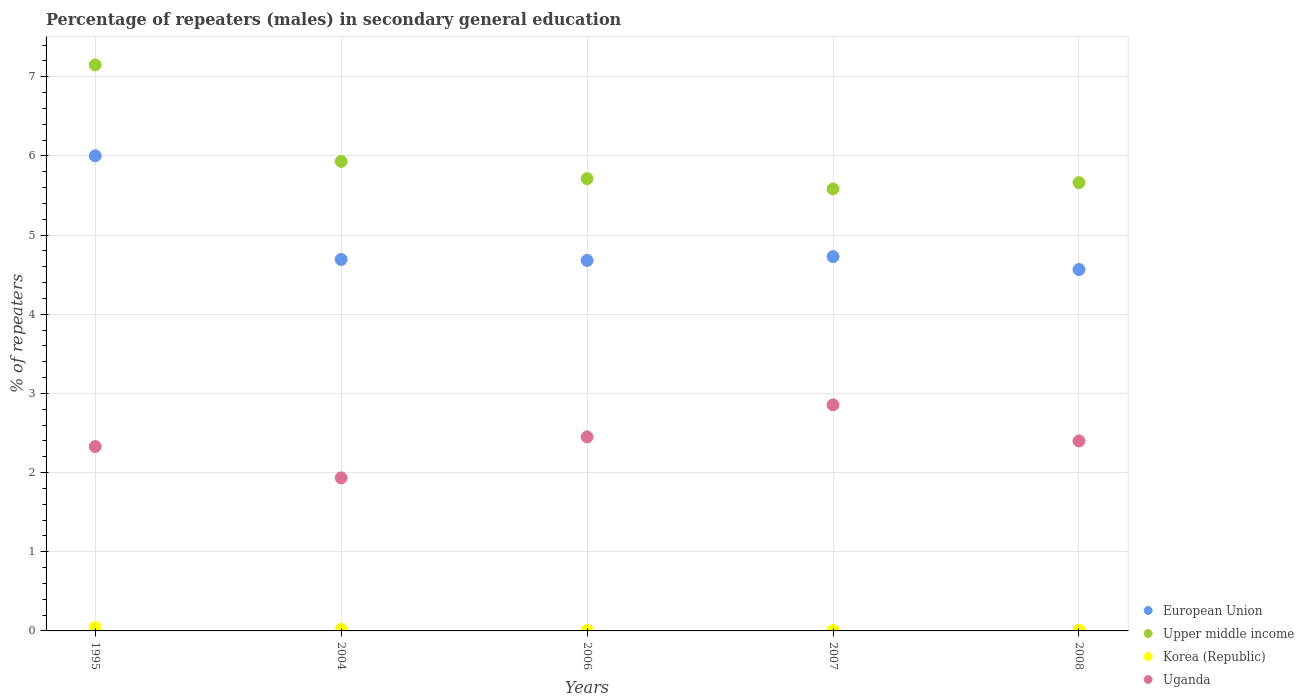How many different coloured dotlines are there?
Offer a very short reply. 4. Is the number of dotlines equal to the number of legend labels?
Provide a short and direct response. Yes. What is the percentage of male repeaters in European Union in 2008?
Offer a terse response. 4.57. Across all years, what is the maximum percentage of male repeaters in Upper middle income?
Your answer should be compact. 7.15. Across all years, what is the minimum percentage of male repeaters in Upper middle income?
Your response must be concise. 5.58. In which year was the percentage of male repeaters in European Union minimum?
Your answer should be very brief. 2008. What is the total percentage of male repeaters in Uganda in the graph?
Offer a very short reply. 11.97. What is the difference between the percentage of male repeaters in European Union in 2004 and that in 2006?
Make the answer very short. 0.01. What is the difference between the percentage of male repeaters in Korea (Republic) in 2006 and the percentage of male repeaters in Uganda in 2007?
Your response must be concise. -2.85. What is the average percentage of male repeaters in European Union per year?
Ensure brevity in your answer.  4.93. In the year 2004, what is the difference between the percentage of male repeaters in Upper middle income and percentage of male repeaters in Korea (Republic)?
Make the answer very short. 5.91. In how many years, is the percentage of male repeaters in Uganda greater than 5.2 %?
Offer a terse response. 0. What is the ratio of the percentage of male repeaters in Korea (Republic) in 2004 to that in 2008?
Make the answer very short. 2.45. Is the percentage of male repeaters in European Union in 1995 less than that in 2008?
Your answer should be compact. No. What is the difference between the highest and the second highest percentage of male repeaters in European Union?
Make the answer very short. 1.27. What is the difference between the highest and the lowest percentage of male repeaters in European Union?
Provide a succinct answer. 1.44. In how many years, is the percentage of male repeaters in European Union greater than the average percentage of male repeaters in European Union taken over all years?
Your answer should be very brief. 1. Is the sum of the percentage of male repeaters in European Union in 2006 and 2007 greater than the maximum percentage of male repeaters in Uganda across all years?
Ensure brevity in your answer.  Yes. How many years are there in the graph?
Provide a succinct answer. 5. What is the difference between two consecutive major ticks on the Y-axis?
Offer a terse response. 1. Does the graph contain any zero values?
Provide a succinct answer. No. Does the graph contain grids?
Make the answer very short. Yes. Where does the legend appear in the graph?
Keep it short and to the point. Bottom right. How are the legend labels stacked?
Ensure brevity in your answer.  Vertical. What is the title of the graph?
Your response must be concise. Percentage of repeaters (males) in secondary general education. What is the label or title of the X-axis?
Make the answer very short. Years. What is the label or title of the Y-axis?
Make the answer very short. % of repeaters. What is the % of repeaters in European Union in 1995?
Give a very brief answer. 6. What is the % of repeaters in Upper middle income in 1995?
Ensure brevity in your answer.  7.15. What is the % of repeaters in Korea (Republic) in 1995?
Your answer should be very brief. 0.04. What is the % of repeaters of Uganda in 1995?
Make the answer very short. 2.33. What is the % of repeaters in European Union in 2004?
Offer a very short reply. 4.69. What is the % of repeaters in Upper middle income in 2004?
Provide a succinct answer. 5.93. What is the % of repeaters in Korea (Republic) in 2004?
Keep it short and to the point. 0.02. What is the % of repeaters in Uganda in 2004?
Give a very brief answer. 1.93. What is the % of repeaters of European Union in 2006?
Make the answer very short. 4.68. What is the % of repeaters of Upper middle income in 2006?
Provide a short and direct response. 5.71. What is the % of repeaters of Korea (Republic) in 2006?
Your response must be concise. 0.01. What is the % of repeaters in Uganda in 2006?
Ensure brevity in your answer.  2.45. What is the % of repeaters of European Union in 2007?
Make the answer very short. 4.73. What is the % of repeaters in Upper middle income in 2007?
Provide a succinct answer. 5.58. What is the % of repeaters in Korea (Republic) in 2007?
Give a very brief answer. 0. What is the % of repeaters of Uganda in 2007?
Your answer should be compact. 2.86. What is the % of repeaters in European Union in 2008?
Keep it short and to the point. 4.57. What is the % of repeaters of Upper middle income in 2008?
Provide a short and direct response. 5.66. What is the % of repeaters of Korea (Republic) in 2008?
Your response must be concise. 0.01. What is the % of repeaters in Uganda in 2008?
Give a very brief answer. 2.4. Across all years, what is the maximum % of repeaters in European Union?
Your answer should be very brief. 6. Across all years, what is the maximum % of repeaters in Upper middle income?
Make the answer very short. 7.15. Across all years, what is the maximum % of repeaters of Korea (Republic)?
Your answer should be very brief. 0.04. Across all years, what is the maximum % of repeaters in Uganda?
Provide a succinct answer. 2.86. Across all years, what is the minimum % of repeaters in European Union?
Give a very brief answer. 4.57. Across all years, what is the minimum % of repeaters of Upper middle income?
Make the answer very short. 5.58. Across all years, what is the minimum % of repeaters in Korea (Republic)?
Provide a succinct answer. 0. Across all years, what is the minimum % of repeaters in Uganda?
Make the answer very short. 1.93. What is the total % of repeaters in European Union in the graph?
Provide a short and direct response. 24.67. What is the total % of repeaters in Upper middle income in the graph?
Your answer should be very brief. 30.04. What is the total % of repeaters in Korea (Republic) in the graph?
Provide a short and direct response. 0.08. What is the total % of repeaters in Uganda in the graph?
Provide a succinct answer. 11.97. What is the difference between the % of repeaters of European Union in 1995 and that in 2004?
Offer a very short reply. 1.31. What is the difference between the % of repeaters of Upper middle income in 1995 and that in 2004?
Make the answer very short. 1.22. What is the difference between the % of repeaters of Korea (Republic) in 1995 and that in 2004?
Offer a terse response. 0.02. What is the difference between the % of repeaters in Uganda in 1995 and that in 2004?
Keep it short and to the point. 0.4. What is the difference between the % of repeaters in European Union in 1995 and that in 2006?
Give a very brief answer. 1.32. What is the difference between the % of repeaters of Upper middle income in 1995 and that in 2006?
Your answer should be compact. 1.44. What is the difference between the % of repeaters in Korea (Republic) in 1995 and that in 2006?
Offer a terse response. 0.04. What is the difference between the % of repeaters in Uganda in 1995 and that in 2006?
Your response must be concise. -0.12. What is the difference between the % of repeaters of European Union in 1995 and that in 2007?
Provide a short and direct response. 1.27. What is the difference between the % of repeaters in Upper middle income in 1995 and that in 2007?
Offer a terse response. 1.57. What is the difference between the % of repeaters of Korea (Republic) in 1995 and that in 2007?
Keep it short and to the point. 0.04. What is the difference between the % of repeaters in Uganda in 1995 and that in 2007?
Offer a very short reply. -0.53. What is the difference between the % of repeaters in European Union in 1995 and that in 2008?
Provide a short and direct response. 1.44. What is the difference between the % of repeaters in Upper middle income in 1995 and that in 2008?
Your response must be concise. 1.49. What is the difference between the % of repeaters in Korea (Republic) in 1995 and that in 2008?
Offer a very short reply. 0.03. What is the difference between the % of repeaters of Uganda in 1995 and that in 2008?
Provide a short and direct response. -0.07. What is the difference between the % of repeaters of European Union in 2004 and that in 2006?
Offer a very short reply. 0.01. What is the difference between the % of repeaters in Upper middle income in 2004 and that in 2006?
Provide a short and direct response. 0.22. What is the difference between the % of repeaters of Korea (Republic) in 2004 and that in 2006?
Provide a short and direct response. 0.01. What is the difference between the % of repeaters in Uganda in 2004 and that in 2006?
Your answer should be compact. -0.52. What is the difference between the % of repeaters in European Union in 2004 and that in 2007?
Offer a very short reply. -0.04. What is the difference between the % of repeaters of Upper middle income in 2004 and that in 2007?
Offer a terse response. 0.35. What is the difference between the % of repeaters of Korea (Republic) in 2004 and that in 2007?
Make the answer very short. 0.02. What is the difference between the % of repeaters in Uganda in 2004 and that in 2007?
Give a very brief answer. -0.92. What is the difference between the % of repeaters in European Union in 2004 and that in 2008?
Provide a succinct answer. 0.13. What is the difference between the % of repeaters of Upper middle income in 2004 and that in 2008?
Give a very brief answer. 0.27. What is the difference between the % of repeaters of Korea (Republic) in 2004 and that in 2008?
Your response must be concise. 0.01. What is the difference between the % of repeaters of Uganda in 2004 and that in 2008?
Offer a very short reply. -0.47. What is the difference between the % of repeaters in European Union in 2006 and that in 2007?
Offer a very short reply. -0.05. What is the difference between the % of repeaters of Upper middle income in 2006 and that in 2007?
Your response must be concise. 0.13. What is the difference between the % of repeaters in Uganda in 2006 and that in 2007?
Provide a succinct answer. -0.4. What is the difference between the % of repeaters of European Union in 2006 and that in 2008?
Make the answer very short. 0.11. What is the difference between the % of repeaters in Upper middle income in 2006 and that in 2008?
Your answer should be compact. 0.05. What is the difference between the % of repeaters in Korea (Republic) in 2006 and that in 2008?
Keep it short and to the point. -0. What is the difference between the % of repeaters in Uganda in 2006 and that in 2008?
Offer a very short reply. 0.05. What is the difference between the % of repeaters in European Union in 2007 and that in 2008?
Your answer should be very brief. 0.16. What is the difference between the % of repeaters in Upper middle income in 2007 and that in 2008?
Your response must be concise. -0.08. What is the difference between the % of repeaters in Korea (Republic) in 2007 and that in 2008?
Ensure brevity in your answer.  -0. What is the difference between the % of repeaters in Uganda in 2007 and that in 2008?
Give a very brief answer. 0.46. What is the difference between the % of repeaters of European Union in 1995 and the % of repeaters of Upper middle income in 2004?
Your answer should be compact. 0.07. What is the difference between the % of repeaters of European Union in 1995 and the % of repeaters of Korea (Republic) in 2004?
Provide a succinct answer. 5.98. What is the difference between the % of repeaters in European Union in 1995 and the % of repeaters in Uganda in 2004?
Keep it short and to the point. 4.07. What is the difference between the % of repeaters in Upper middle income in 1995 and the % of repeaters in Korea (Republic) in 2004?
Offer a terse response. 7.13. What is the difference between the % of repeaters in Upper middle income in 1995 and the % of repeaters in Uganda in 2004?
Offer a very short reply. 5.22. What is the difference between the % of repeaters in Korea (Republic) in 1995 and the % of repeaters in Uganda in 2004?
Make the answer very short. -1.89. What is the difference between the % of repeaters of European Union in 1995 and the % of repeaters of Upper middle income in 2006?
Make the answer very short. 0.29. What is the difference between the % of repeaters of European Union in 1995 and the % of repeaters of Korea (Republic) in 2006?
Your response must be concise. 6. What is the difference between the % of repeaters of European Union in 1995 and the % of repeaters of Uganda in 2006?
Make the answer very short. 3.55. What is the difference between the % of repeaters of Upper middle income in 1995 and the % of repeaters of Korea (Republic) in 2006?
Keep it short and to the point. 7.15. What is the difference between the % of repeaters of Upper middle income in 1995 and the % of repeaters of Uganda in 2006?
Your answer should be very brief. 4.7. What is the difference between the % of repeaters in Korea (Republic) in 1995 and the % of repeaters in Uganda in 2006?
Make the answer very short. -2.41. What is the difference between the % of repeaters of European Union in 1995 and the % of repeaters of Upper middle income in 2007?
Offer a terse response. 0.42. What is the difference between the % of repeaters in European Union in 1995 and the % of repeaters in Korea (Republic) in 2007?
Provide a succinct answer. 6. What is the difference between the % of repeaters in European Union in 1995 and the % of repeaters in Uganda in 2007?
Provide a short and direct response. 3.15. What is the difference between the % of repeaters of Upper middle income in 1995 and the % of repeaters of Korea (Republic) in 2007?
Make the answer very short. 7.15. What is the difference between the % of repeaters of Upper middle income in 1995 and the % of repeaters of Uganda in 2007?
Offer a very short reply. 4.29. What is the difference between the % of repeaters of Korea (Republic) in 1995 and the % of repeaters of Uganda in 2007?
Provide a succinct answer. -2.81. What is the difference between the % of repeaters of European Union in 1995 and the % of repeaters of Upper middle income in 2008?
Offer a terse response. 0.34. What is the difference between the % of repeaters of European Union in 1995 and the % of repeaters of Korea (Republic) in 2008?
Keep it short and to the point. 5.99. What is the difference between the % of repeaters of European Union in 1995 and the % of repeaters of Uganda in 2008?
Make the answer very short. 3.6. What is the difference between the % of repeaters of Upper middle income in 1995 and the % of repeaters of Korea (Republic) in 2008?
Make the answer very short. 7.14. What is the difference between the % of repeaters of Upper middle income in 1995 and the % of repeaters of Uganda in 2008?
Your answer should be very brief. 4.75. What is the difference between the % of repeaters in Korea (Republic) in 1995 and the % of repeaters in Uganda in 2008?
Your answer should be compact. -2.36. What is the difference between the % of repeaters of European Union in 2004 and the % of repeaters of Upper middle income in 2006?
Make the answer very short. -1.02. What is the difference between the % of repeaters of European Union in 2004 and the % of repeaters of Korea (Republic) in 2006?
Your response must be concise. 4.69. What is the difference between the % of repeaters of European Union in 2004 and the % of repeaters of Uganda in 2006?
Give a very brief answer. 2.24. What is the difference between the % of repeaters in Upper middle income in 2004 and the % of repeaters in Korea (Republic) in 2006?
Ensure brevity in your answer.  5.93. What is the difference between the % of repeaters in Upper middle income in 2004 and the % of repeaters in Uganda in 2006?
Your answer should be compact. 3.48. What is the difference between the % of repeaters in Korea (Republic) in 2004 and the % of repeaters in Uganda in 2006?
Ensure brevity in your answer.  -2.43. What is the difference between the % of repeaters in European Union in 2004 and the % of repeaters in Upper middle income in 2007?
Offer a very short reply. -0.89. What is the difference between the % of repeaters in European Union in 2004 and the % of repeaters in Korea (Republic) in 2007?
Provide a short and direct response. 4.69. What is the difference between the % of repeaters of European Union in 2004 and the % of repeaters of Uganda in 2007?
Your response must be concise. 1.84. What is the difference between the % of repeaters of Upper middle income in 2004 and the % of repeaters of Korea (Republic) in 2007?
Make the answer very short. 5.93. What is the difference between the % of repeaters of Upper middle income in 2004 and the % of repeaters of Uganda in 2007?
Keep it short and to the point. 3.08. What is the difference between the % of repeaters in Korea (Republic) in 2004 and the % of repeaters in Uganda in 2007?
Your response must be concise. -2.84. What is the difference between the % of repeaters in European Union in 2004 and the % of repeaters in Upper middle income in 2008?
Make the answer very short. -0.97. What is the difference between the % of repeaters in European Union in 2004 and the % of repeaters in Korea (Republic) in 2008?
Keep it short and to the point. 4.68. What is the difference between the % of repeaters of European Union in 2004 and the % of repeaters of Uganda in 2008?
Offer a very short reply. 2.29. What is the difference between the % of repeaters of Upper middle income in 2004 and the % of repeaters of Korea (Republic) in 2008?
Your answer should be very brief. 5.92. What is the difference between the % of repeaters in Upper middle income in 2004 and the % of repeaters in Uganda in 2008?
Your answer should be very brief. 3.53. What is the difference between the % of repeaters in Korea (Republic) in 2004 and the % of repeaters in Uganda in 2008?
Give a very brief answer. -2.38. What is the difference between the % of repeaters in European Union in 2006 and the % of repeaters in Upper middle income in 2007?
Keep it short and to the point. -0.9. What is the difference between the % of repeaters in European Union in 2006 and the % of repeaters in Korea (Republic) in 2007?
Offer a terse response. 4.68. What is the difference between the % of repeaters of European Union in 2006 and the % of repeaters of Uganda in 2007?
Offer a terse response. 1.82. What is the difference between the % of repeaters of Upper middle income in 2006 and the % of repeaters of Korea (Republic) in 2007?
Keep it short and to the point. 5.71. What is the difference between the % of repeaters of Upper middle income in 2006 and the % of repeaters of Uganda in 2007?
Your answer should be very brief. 2.86. What is the difference between the % of repeaters of Korea (Republic) in 2006 and the % of repeaters of Uganda in 2007?
Give a very brief answer. -2.85. What is the difference between the % of repeaters of European Union in 2006 and the % of repeaters of Upper middle income in 2008?
Offer a terse response. -0.98. What is the difference between the % of repeaters of European Union in 2006 and the % of repeaters of Korea (Republic) in 2008?
Offer a terse response. 4.67. What is the difference between the % of repeaters of European Union in 2006 and the % of repeaters of Uganda in 2008?
Give a very brief answer. 2.28. What is the difference between the % of repeaters in Upper middle income in 2006 and the % of repeaters in Korea (Republic) in 2008?
Make the answer very short. 5.71. What is the difference between the % of repeaters of Upper middle income in 2006 and the % of repeaters of Uganda in 2008?
Keep it short and to the point. 3.31. What is the difference between the % of repeaters in Korea (Republic) in 2006 and the % of repeaters in Uganda in 2008?
Give a very brief answer. -2.39. What is the difference between the % of repeaters in European Union in 2007 and the % of repeaters in Upper middle income in 2008?
Your response must be concise. -0.93. What is the difference between the % of repeaters in European Union in 2007 and the % of repeaters in Korea (Republic) in 2008?
Provide a succinct answer. 4.72. What is the difference between the % of repeaters in European Union in 2007 and the % of repeaters in Uganda in 2008?
Offer a very short reply. 2.33. What is the difference between the % of repeaters of Upper middle income in 2007 and the % of repeaters of Korea (Republic) in 2008?
Your answer should be very brief. 5.58. What is the difference between the % of repeaters in Upper middle income in 2007 and the % of repeaters in Uganda in 2008?
Your answer should be very brief. 3.18. What is the difference between the % of repeaters in Korea (Republic) in 2007 and the % of repeaters in Uganda in 2008?
Your answer should be compact. -2.39. What is the average % of repeaters of European Union per year?
Offer a terse response. 4.93. What is the average % of repeaters in Upper middle income per year?
Your response must be concise. 6.01. What is the average % of repeaters in Korea (Republic) per year?
Offer a terse response. 0.02. What is the average % of repeaters of Uganda per year?
Keep it short and to the point. 2.39. In the year 1995, what is the difference between the % of repeaters of European Union and % of repeaters of Upper middle income?
Provide a succinct answer. -1.15. In the year 1995, what is the difference between the % of repeaters in European Union and % of repeaters in Korea (Republic)?
Offer a very short reply. 5.96. In the year 1995, what is the difference between the % of repeaters of European Union and % of repeaters of Uganda?
Ensure brevity in your answer.  3.67. In the year 1995, what is the difference between the % of repeaters of Upper middle income and % of repeaters of Korea (Republic)?
Offer a terse response. 7.11. In the year 1995, what is the difference between the % of repeaters in Upper middle income and % of repeaters in Uganda?
Your answer should be very brief. 4.82. In the year 1995, what is the difference between the % of repeaters in Korea (Republic) and % of repeaters in Uganda?
Ensure brevity in your answer.  -2.29. In the year 2004, what is the difference between the % of repeaters in European Union and % of repeaters in Upper middle income?
Give a very brief answer. -1.24. In the year 2004, what is the difference between the % of repeaters in European Union and % of repeaters in Korea (Republic)?
Your response must be concise. 4.67. In the year 2004, what is the difference between the % of repeaters of European Union and % of repeaters of Uganda?
Give a very brief answer. 2.76. In the year 2004, what is the difference between the % of repeaters in Upper middle income and % of repeaters in Korea (Republic)?
Ensure brevity in your answer.  5.91. In the year 2004, what is the difference between the % of repeaters in Upper middle income and % of repeaters in Uganda?
Make the answer very short. 4. In the year 2004, what is the difference between the % of repeaters of Korea (Republic) and % of repeaters of Uganda?
Offer a terse response. -1.91. In the year 2006, what is the difference between the % of repeaters in European Union and % of repeaters in Upper middle income?
Give a very brief answer. -1.03. In the year 2006, what is the difference between the % of repeaters of European Union and % of repeaters of Korea (Republic)?
Offer a terse response. 4.67. In the year 2006, what is the difference between the % of repeaters of European Union and % of repeaters of Uganda?
Your response must be concise. 2.23. In the year 2006, what is the difference between the % of repeaters in Upper middle income and % of repeaters in Korea (Republic)?
Keep it short and to the point. 5.71. In the year 2006, what is the difference between the % of repeaters in Upper middle income and % of repeaters in Uganda?
Your answer should be compact. 3.26. In the year 2006, what is the difference between the % of repeaters in Korea (Republic) and % of repeaters in Uganda?
Your response must be concise. -2.45. In the year 2007, what is the difference between the % of repeaters of European Union and % of repeaters of Upper middle income?
Offer a terse response. -0.85. In the year 2007, what is the difference between the % of repeaters in European Union and % of repeaters in Korea (Republic)?
Provide a succinct answer. 4.72. In the year 2007, what is the difference between the % of repeaters of European Union and % of repeaters of Uganda?
Make the answer very short. 1.87. In the year 2007, what is the difference between the % of repeaters of Upper middle income and % of repeaters of Korea (Republic)?
Keep it short and to the point. 5.58. In the year 2007, what is the difference between the % of repeaters of Upper middle income and % of repeaters of Uganda?
Offer a very short reply. 2.73. In the year 2007, what is the difference between the % of repeaters in Korea (Republic) and % of repeaters in Uganda?
Your answer should be compact. -2.85. In the year 2008, what is the difference between the % of repeaters of European Union and % of repeaters of Upper middle income?
Make the answer very short. -1.1. In the year 2008, what is the difference between the % of repeaters of European Union and % of repeaters of Korea (Republic)?
Keep it short and to the point. 4.56. In the year 2008, what is the difference between the % of repeaters of European Union and % of repeaters of Uganda?
Offer a terse response. 2.17. In the year 2008, what is the difference between the % of repeaters of Upper middle income and % of repeaters of Korea (Republic)?
Ensure brevity in your answer.  5.65. In the year 2008, what is the difference between the % of repeaters in Upper middle income and % of repeaters in Uganda?
Your answer should be very brief. 3.26. In the year 2008, what is the difference between the % of repeaters in Korea (Republic) and % of repeaters in Uganda?
Ensure brevity in your answer.  -2.39. What is the ratio of the % of repeaters of European Union in 1995 to that in 2004?
Give a very brief answer. 1.28. What is the ratio of the % of repeaters of Upper middle income in 1995 to that in 2004?
Give a very brief answer. 1.21. What is the ratio of the % of repeaters of Korea (Republic) in 1995 to that in 2004?
Your answer should be very brief. 2.12. What is the ratio of the % of repeaters of Uganda in 1995 to that in 2004?
Your answer should be very brief. 1.2. What is the ratio of the % of repeaters in European Union in 1995 to that in 2006?
Offer a terse response. 1.28. What is the ratio of the % of repeaters in Upper middle income in 1995 to that in 2006?
Your answer should be very brief. 1.25. What is the ratio of the % of repeaters in Korea (Republic) in 1995 to that in 2006?
Your answer should be very brief. 7.9. What is the ratio of the % of repeaters of Uganda in 1995 to that in 2006?
Your answer should be compact. 0.95. What is the ratio of the % of repeaters in European Union in 1995 to that in 2007?
Give a very brief answer. 1.27. What is the ratio of the % of repeaters of Upper middle income in 1995 to that in 2007?
Provide a succinct answer. 1.28. What is the ratio of the % of repeaters in Korea (Republic) in 1995 to that in 2007?
Give a very brief answer. 8.79. What is the ratio of the % of repeaters of Uganda in 1995 to that in 2007?
Provide a short and direct response. 0.82. What is the ratio of the % of repeaters in European Union in 1995 to that in 2008?
Your response must be concise. 1.31. What is the ratio of the % of repeaters in Upper middle income in 1995 to that in 2008?
Provide a short and direct response. 1.26. What is the ratio of the % of repeaters of Korea (Republic) in 1995 to that in 2008?
Make the answer very short. 5.19. What is the ratio of the % of repeaters in Uganda in 1995 to that in 2008?
Make the answer very short. 0.97. What is the ratio of the % of repeaters in European Union in 2004 to that in 2006?
Keep it short and to the point. 1. What is the ratio of the % of repeaters in Upper middle income in 2004 to that in 2006?
Your answer should be very brief. 1.04. What is the ratio of the % of repeaters in Korea (Republic) in 2004 to that in 2006?
Give a very brief answer. 3.73. What is the ratio of the % of repeaters of Uganda in 2004 to that in 2006?
Offer a terse response. 0.79. What is the ratio of the % of repeaters of European Union in 2004 to that in 2007?
Offer a terse response. 0.99. What is the ratio of the % of repeaters of Upper middle income in 2004 to that in 2007?
Provide a short and direct response. 1.06. What is the ratio of the % of repeaters in Korea (Republic) in 2004 to that in 2007?
Give a very brief answer. 4.15. What is the ratio of the % of repeaters of Uganda in 2004 to that in 2007?
Ensure brevity in your answer.  0.68. What is the ratio of the % of repeaters of European Union in 2004 to that in 2008?
Your answer should be very brief. 1.03. What is the ratio of the % of repeaters of Upper middle income in 2004 to that in 2008?
Give a very brief answer. 1.05. What is the ratio of the % of repeaters in Korea (Republic) in 2004 to that in 2008?
Your answer should be very brief. 2.45. What is the ratio of the % of repeaters in Uganda in 2004 to that in 2008?
Ensure brevity in your answer.  0.81. What is the ratio of the % of repeaters of European Union in 2006 to that in 2007?
Offer a very short reply. 0.99. What is the ratio of the % of repeaters in Upper middle income in 2006 to that in 2007?
Offer a very short reply. 1.02. What is the ratio of the % of repeaters in Korea (Republic) in 2006 to that in 2007?
Offer a very short reply. 1.11. What is the ratio of the % of repeaters in Uganda in 2006 to that in 2007?
Offer a terse response. 0.86. What is the ratio of the % of repeaters of European Union in 2006 to that in 2008?
Ensure brevity in your answer.  1.03. What is the ratio of the % of repeaters of Upper middle income in 2006 to that in 2008?
Your response must be concise. 1.01. What is the ratio of the % of repeaters of Korea (Republic) in 2006 to that in 2008?
Your answer should be very brief. 0.66. What is the ratio of the % of repeaters in Uganda in 2006 to that in 2008?
Give a very brief answer. 1.02. What is the ratio of the % of repeaters of European Union in 2007 to that in 2008?
Keep it short and to the point. 1.04. What is the ratio of the % of repeaters in Upper middle income in 2007 to that in 2008?
Provide a short and direct response. 0.99. What is the ratio of the % of repeaters in Korea (Republic) in 2007 to that in 2008?
Offer a terse response. 0.59. What is the ratio of the % of repeaters in Uganda in 2007 to that in 2008?
Offer a very short reply. 1.19. What is the difference between the highest and the second highest % of repeaters of European Union?
Your answer should be compact. 1.27. What is the difference between the highest and the second highest % of repeaters of Upper middle income?
Ensure brevity in your answer.  1.22. What is the difference between the highest and the second highest % of repeaters of Korea (Republic)?
Make the answer very short. 0.02. What is the difference between the highest and the second highest % of repeaters of Uganda?
Provide a succinct answer. 0.4. What is the difference between the highest and the lowest % of repeaters of European Union?
Provide a short and direct response. 1.44. What is the difference between the highest and the lowest % of repeaters of Upper middle income?
Provide a short and direct response. 1.57. What is the difference between the highest and the lowest % of repeaters in Korea (Republic)?
Offer a very short reply. 0.04. What is the difference between the highest and the lowest % of repeaters in Uganda?
Your response must be concise. 0.92. 